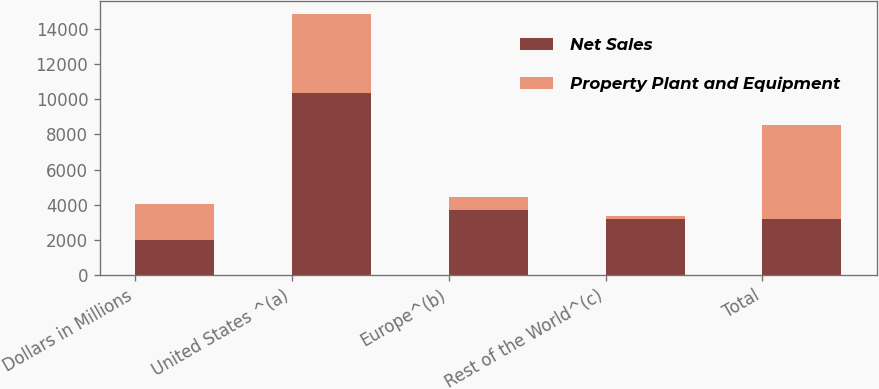<chart> <loc_0><loc_0><loc_500><loc_500><stacked_bar_chart><ecel><fcel>Dollars in Millions<fcel>United States ^(a)<fcel>Europe^(b)<fcel>Rest of the World^(c)<fcel>Total<nl><fcel>Net Sales<fcel>2012<fcel>10384<fcel>3706<fcel>3204<fcel>3204<nl><fcel>Property Plant and Equipment<fcel>2012<fcel>4464<fcel>740<fcel>129<fcel>5333<nl></chart> 